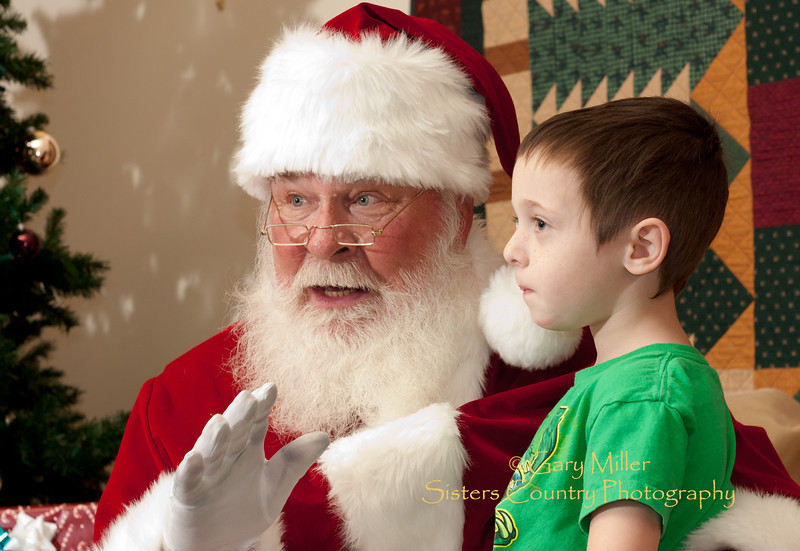How does Santa's expression contribute to the atmosphere of the meeting depicted in the image? Santa’s cheerful and animated expression contributes significantly to a jovial and spirited atmosphere. His bright eyes and broad smile, coupled with an engaging gesture, portray a warm and inviting presence, likely making the child feel more at ease and cherished in the moment. 